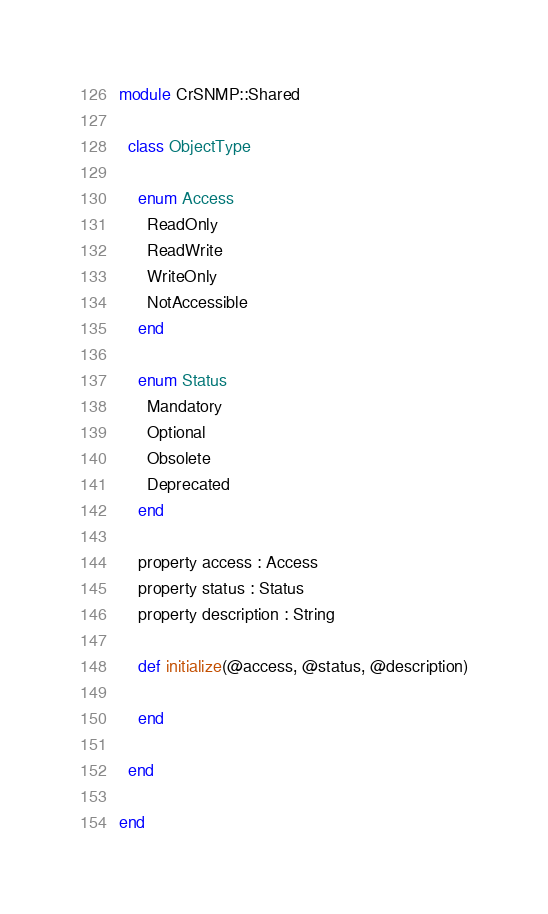Convert code to text. <code><loc_0><loc_0><loc_500><loc_500><_Crystal_>module CrSNMP::Shared

  class ObjectType

    enum Access
      ReadOnly
      ReadWrite
      WriteOnly
      NotAccessible
    end

    enum Status
      Mandatory
      Optional
      Obsolete
      Deprecated
    end

    property access : Access
    property status : Status
    property description : String

    def initialize(@access, @status, @description)

    end

  end

end
</code> 